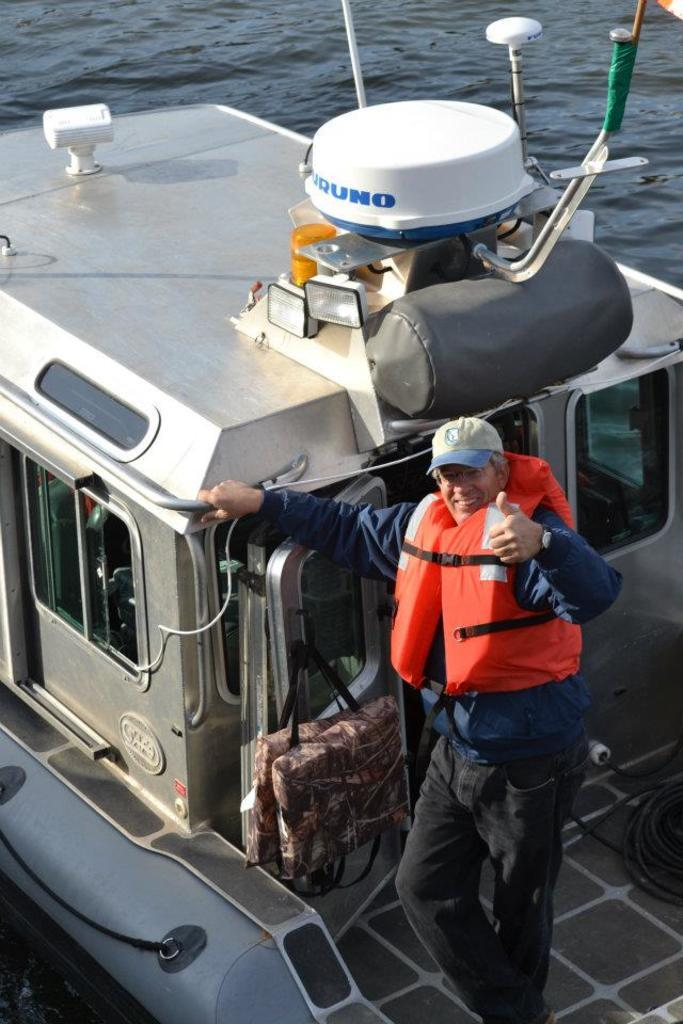Who or what is present in the image? There is a person in the image. What is the person wearing? The person is wearing a jacket. Where is the person located? The person is standing on a ship. What can be seen in the background of the image? There is water visible in the background of the image. Where is the lunchroom located on the ship in the image? There is no mention of a lunchroom in the image; it only shows a person standing on a ship. 